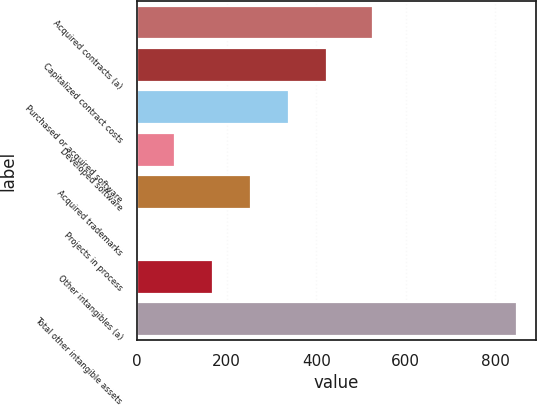<chart> <loc_0><loc_0><loc_500><loc_500><bar_chart><fcel>Acquired contracts (a)<fcel>Capitalized contract costs<fcel>Purchased or acquired software<fcel>Developed software<fcel>Acquired trademarks<fcel>Projects in process<fcel>Other intangibles (a)<fcel>Total other intangible assets<nl><fcel>526.5<fcel>424.1<fcel>339.44<fcel>85.46<fcel>254.78<fcel>0.8<fcel>170.12<fcel>847.4<nl></chart> 